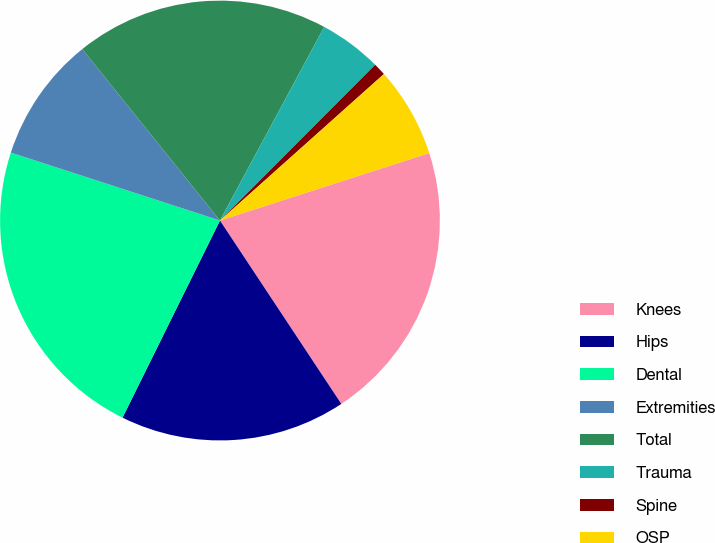Convert chart to OTSL. <chart><loc_0><loc_0><loc_500><loc_500><pie_chart><fcel>Knees<fcel>Hips<fcel>Dental<fcel>Extremities<fcel>Total<fcel>Trauma<fcel>Spine<fcel>OSP<nl><fcel>20.66%<fcel>16.61%<fcel>22.69%<fcel>9.23%<fcel>18.63%<fcel>4.61%<fcel>0.92%<fcel>6.64%<nl></chart> 